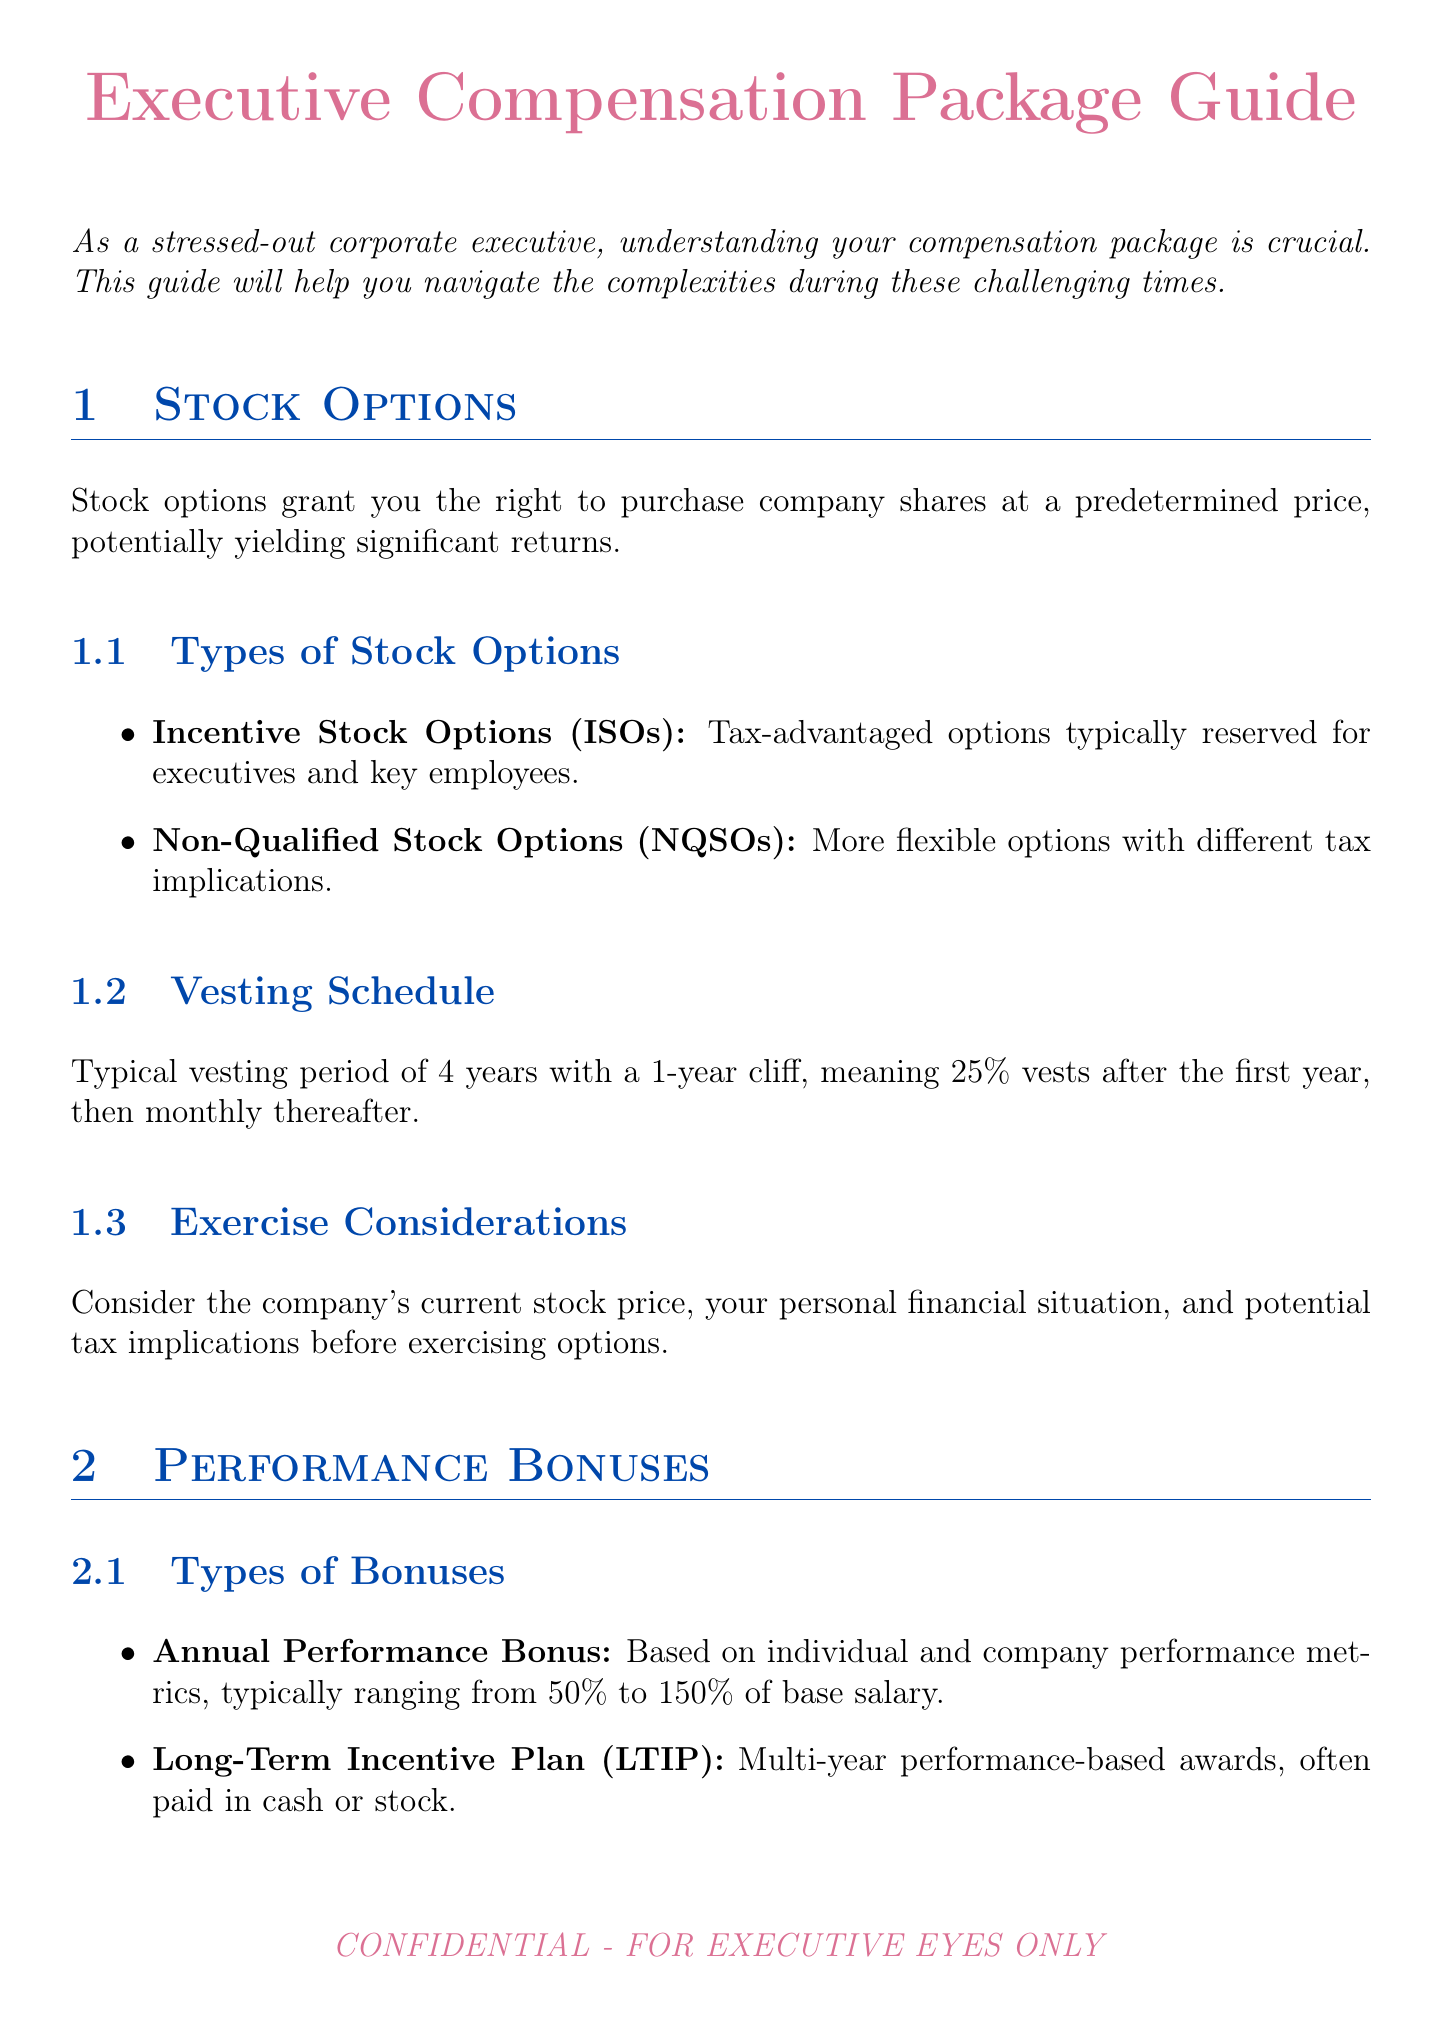What is the typical vesting period for stock options? The typical vesting period mentioned in the document is 4 years with a 1-year cliff.
Answer: 4 years What percentage does the company match in the 401(k) plan? The company matches 100% on the first 5% of salary contributed.
Answer: 100% match on the first 5% What is the range for Annual Performance Bonus as a percentage of base salary? The range for the annual performance bonus is between 50% and 150% of base salary.
Answer: 50% to 150% How long does it take to fully vest in the Supplemental Executive Retirement Plan (SERP)? Full vesting in the SERP occurs after 10 years of service or age 65, whichever comes first.
Answer: 10 years What are two types of stock options listed in the document? The two types of stock options mentioned are Incentive Stock Options (ISOs) and Non-Qualified Stock Options (NQSOs).
Answer: ISOs and NQSOs What should you consult regarding tax planning? The document advises consulting with a tax advisor to optimize the timing of stock option exercises and bonus payouts.
Answer: Tax advisor What is one key performance indicator for performance bonuses? One key performance indicator listed is EBITDA growth.
Answer: EBITDA growth Name one resource provided for stress management. One of the resources mentioned for stress management is a confidential executive counseling hotline.
Answer: Confidential executive counseling hotline What is the benefit formula for the Supplemental Executive Retirement Plan? The benefit formula is 2% of final average salary multiplied by years of service, up to a maximum of 60% of final average salary.
Answer: 2% of final average salary multiplied by years of service 